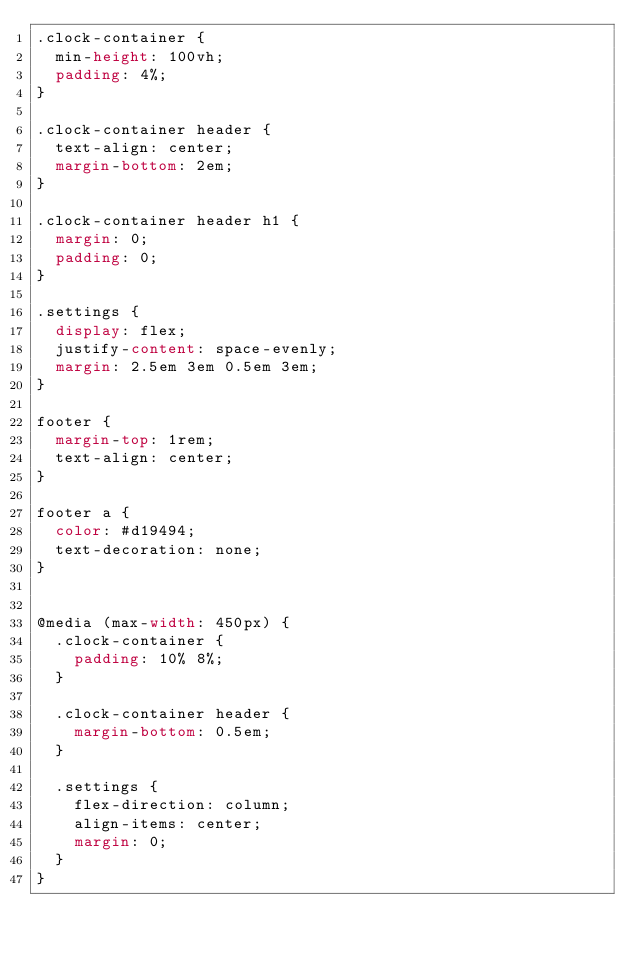<code> <loc_0><loc_0><loc_500><loc_500><_CSS_>.clock-container {
  min-height: 100vh;
  padding: 4%;
}

.clock-container header {
  text-align: center;
  margin-bottom: 2em;
}

.clock-container header h1 {
  margin: 0;
  padding: 0;
}

.settings {
  display: flex;
  justify-content: space-evenly;
  margin: 2.5em 3em 0.5em 3em;
}

footer {
  margin-top: 1rem;
  text-align: center;
}

footer a {
  color: #d19494;
  text-decoration: none;
}


@media (max-width: 450px) {
  .clock-container {
    padding: 10% 8%;
  }

  .clock-container header {
    margin-bottom: 0.5em;
  }

  .settings {
    flex-direction: column;
    align-items: center;
    margin: 0;
  }
}
</code> 